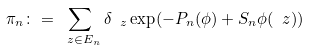<formula> <loc_0><loc_0><loc_500><loc_500>\pi _ { n } \colon = \sum _ { \ z \in E _ { n } } \delta _ { \ z } \exp ( - P _ { n } ( \phi ) + S _ { n } \phi ( \ z ) )</formula> 